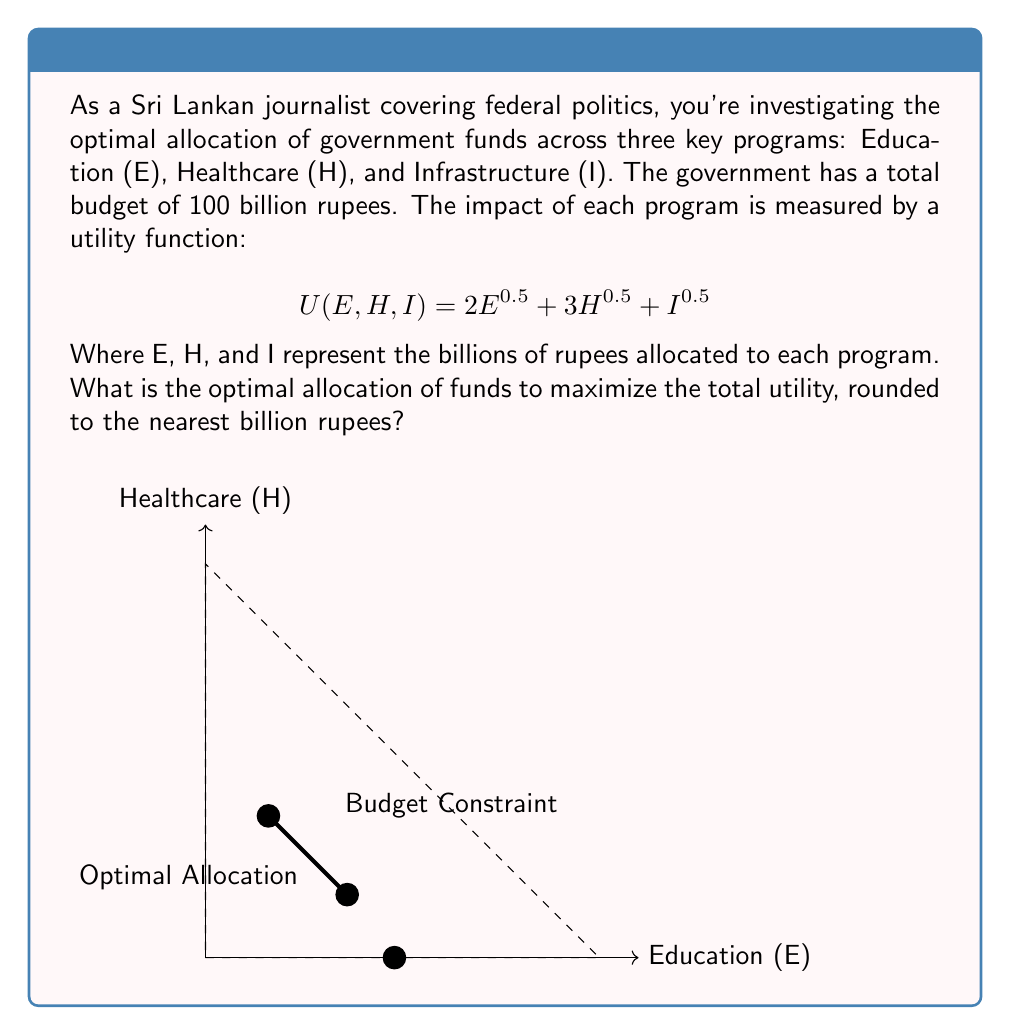Solve this math problem. To solve this optimization problem, we'll use the method of Lagrange multipliers:

1) Set up the Lagrangian function:
   $$L(E,H,I,\lambda) = 2E^{0.5} + 3H^{0.5} + I^{0.5} - \lambda(E + H + I - 100)$$

2) Take partial derivatives and set them equal to zero:
   $$\frac{\partial L}{\partial E} = E^{-0.5} - \lambda = 0$$
   $$\frac{\partial L}{\partial H} = \frac{3}{2}H^{-0.5} - \lambda = 0$$
   $$\frac{\partial L}{\partial I} = \frac{1}{2}I^{-0.5} - \lambda = 0$$
   $$\frac{\partial L}{\partial \lambda} = E + H + I - 100 = 0$$

3) From these equations, we can derive:
   $$E^{-0.5} = \frac{3}{2}H^{-0.5} = \frac{1}{2}I^{-0.5} = \lambda$$

4) This implies:
   $$E = \frac{4}{9}H \quad \text{and} \quad I = \frac{1}{4}H$$

5) Substituting into the budget constraint:
   $$\frac{4}{9}H + H + \frac{1}{4}H = 100$$
   $$\frac{49}{36}H = 100$$
   $$H = \frac{3600}{49} \approx 73.47$$

6) Solving for E and I:
   $$E = \frac{4}{9} \cdot \frac{3600}{49} \approx 32.65$$
   $$I = \frac{1}{4} \cdot \frac{3600}{49} \approx 18.37$$

7) Rounding to the nearest billion:
   E = 33, H = 73, I = 18
Answer: E = 33 billion, H = 73 billion, I = 18 billion 